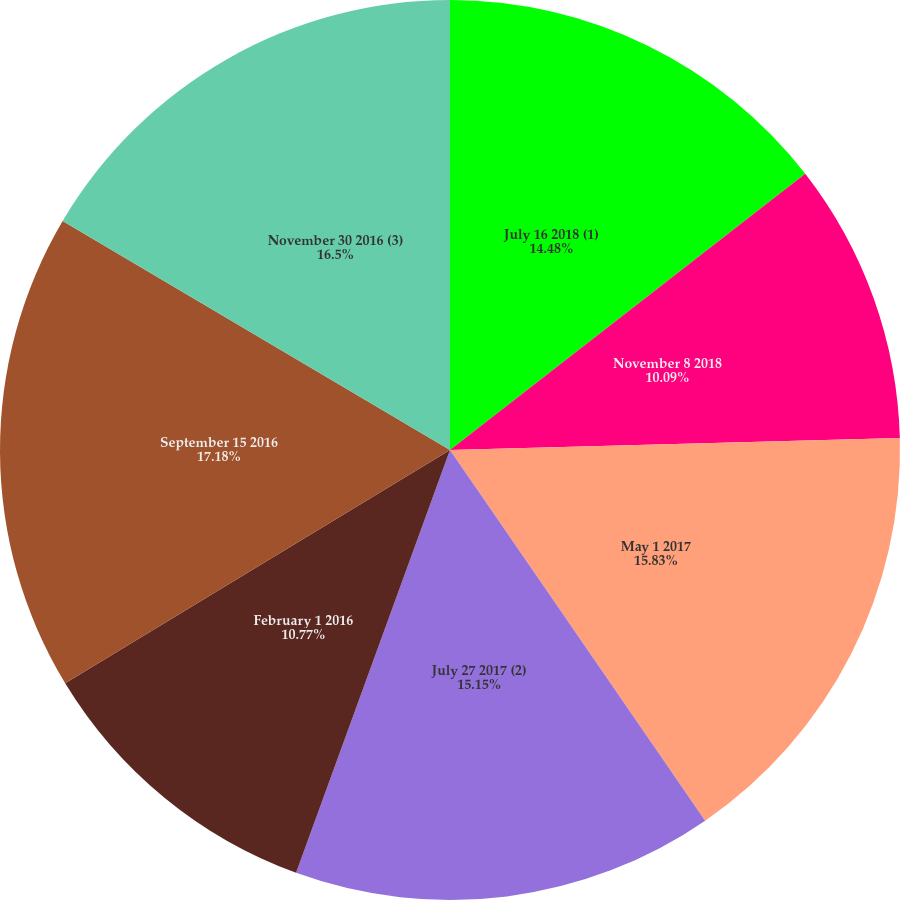<chart> <loc_0><loc_0><loc_500><loc_500><pie_chart><fcel>July 16 2018 (1)<fcel>November 8 2018<fcel>May 1 2017<fcel>July 27 2017 (2)<fcel>February 1 2016<fcel>September 15 2016<fcel>November 30 2016 (3)<nl><fcel>14.48%<fcel>10.09%<fcel>15.83%<fcel>15.15%<fcel>10.77%<fcel>17.17%<fcel>16.5%<nl></chart> 